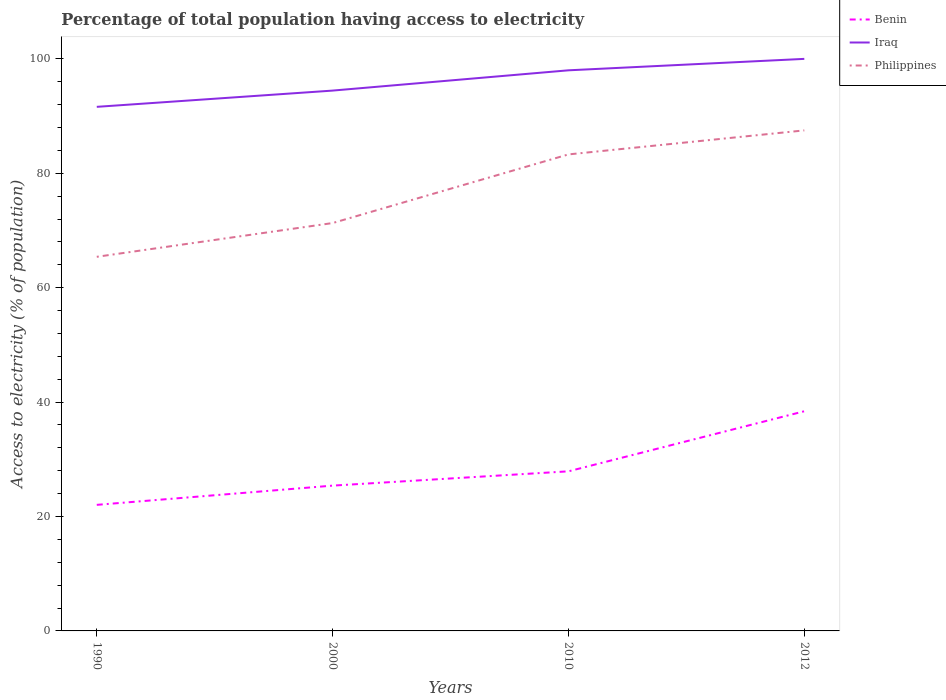How many different coloured lines are there?
Offer a terse response. 3. Across all years, what is the maximum percentage of population that have access to electricity in Benin?
Give a very brief answer. 22.04. What is the total percentage of population that have access to electricity in Philippines in the graph?
Ensure brevity in your answer.  -16.2. What is the difference between the highest and the second highest percentage of population that have access to electricity in Benin?
Your answer should be very brief. 16.36. What is the difference between the highest and the lowest percentage of population that have access to electricity in Benin?
Your answer should be very brief. 1. How many lines are there?
Offer a terse response. 3. How many years are there in the graph?
Provide a short and direct response. 4. Are the values on the major ticks of Y-axis written in scientific E-notation?
Provide a succinct answer. No. How many legend labels are there?
Make the answer very short. 3. What is the title of the graph?
Offer a terse response. Percentage of total population having access to electricity. Does "Chad" appear as one of the legend labels in the graph?
Keep it short and to the point. No. What is the label or title of the X-axis?
Your answer should be compact. Years. What is the label or title of the Y-axis?
Provide a short and direct response. Access to electricity (% of population). What is the Access to electricity (% of population) of Benin in 1990?
Your answer should be compact. 22.04. What is the Access to electricity (% of population) of Iraq in 1990?
Ensure brevity in your answer.  91.62. What is the Access to electricity (% of population) of Philippines in 1990?
Ensure brevity in your answer.  65.4. What is the Access to electricity (% of population) in Benin in 2000?
Make the answer very short. 25.4. What is the Access to electricity (% of population) in Iraq in 2000?
Give a very brief answer. 94.46. What is the Access to electricity (% of population) in Philippines in 2000?
Offer a very short reply. 71.3. What is the Access to electricity (% of population) of Benin in 2010?
Offer a very short reply. 27.9. What is the Access to electricity (% of population) in Iraq in 2010?
Your answer should be very brief. 98. What is the Access to electricity (% of population) in Philippines in 2010?
Your answer should be very brief. 83.3. What is the Access to electricity (% of population) in Benin in 2012?
Your response must be concise. 38.4. What is the Access to electricity (% of population) of Philippines in 2012?
Provide a succinct answer. 87.5. Across all years, what is the maximum Access to electricity (% of population) in Benin?
Your response must be concise. 38.4. Across all years, what is the maximum Access to electricity (% of population) of Iraq?
Make the answer very short. 100. Across all years, what is the maximum Access to electricity (% of population) of Philippines?
Offer a very short reply. 87.5. Across all years, what is the minimum Access to electricity (% of population) in Benin?
Offer a very short reply. 22.04. Across all years, what is the minimum Access to electricity (% of population) in Iraq?
Provide a short and direct response. 91.62. Across all years, what is the minimum Access to electricity (% of population) in Philippines?
Your response must be concise. 65.4. What is the total Access to electricity (% of population) of Benin in the graph?
Make the answer very short. 113.74. What is the total Access to electricity (% of population) of Iraq in the graph?
Give a very brief answer. 384.07. What is the total Access to electricity (% of population) in Philippines in the graph?
Offer a terse response. 307.5. What is the difference between the Access to electricity (% of population) in Benin in 1990 and that in 2000?
Provide a short and direct response. -3.36. What is the difference between the Access to electricity (% of population) in Iraq in 1990 and that in 2000?
Give a very brief answer. -2.84. What is the difference between the Access to electricity (% of population) of Benin in 1990 and that in 2010?
Provide a succinct answer. -5.86. What is the difference between the Access to electricity (% of population) of Iraq in 1990 and that in 2010?
Provide a short and direct response. -6.38. What is the difference between the Access to electricity (% of population) of Philippines in 1990 and that in 2010?
Keep it short and to the point. -17.9. What is the difference between the Access to electricity (% of population) in Benin in 1990 and that in 2012?
Make the answer very short. -16.36. What is the difference between the Access to electricity (% of population) in Iraq in 1990 and that in 2012?
Your answer should be compact. -8.38. What is the difference between the Access to electricity (% of population) in Philippines in 1990 and that in 2012?
Make the answer very short. -22.1. What is the difference between the Access to electricity (% of population) of Iraq in 2000 and that in 2010?
Your answer should be very brief. -3.54. What is the difference between the Access to electricity (% of population) in Philippines in 2000 and that in 2010?
Your answer should be very brief. -12. What is the difference between the Access to electricity (% of population) of Iraq in 2000 and that in 2012?
Provide a short and direct response. -5.54. What is the difference between the Access to electricity (% of population) of Philippines in 2000 and that in 2012?
Provide a succinct answer. -16.2. What is the difference between the Access to electricity (% of population) in Iraq in 2010 and that in 2012?
Make the answer very short. -2. What is the difference between the Access to electricity (% of population) of Benin in 1990 and the Access to electricity (% of population) of Iraq in 2000?
Keep it short and to the point. -72.42. What is the difference between the Access to electricity (% of population) of Benin in 1990 and the Access to electricity (% of population) of Philippines in 2000?
Provide a short and direct response. -49.26. What is the difference between the Access to electricity (% of population) of Iraq in 1990 and the Access to electricity (% of population) of Philippines in 2000?
Provide a short and direct response. 20.32. What is the difference between the Access to electricity (% of population) in Benin in 1990 and the Access to electricity (% of population) in Iraq in 2010?
Provide a succinct answer. -75.96. What is the difference between the Access to electricity (% of population) of Benin in 1990 and the Access to electricity (% of population) of Philippines in 2010?
Offer a very short reply. -61.26. What is the difference between the Access to electricity (% of population) of Iraq in 1990 and the Access to electricity (% of population) of Philippines in 2010?
Your answer should be compact. 8.32. What is the difference between the Access to electricity (% of population) of Benin in 1990 and the Access to electricity (% of population) of Iraq in 2012?
Give a very brief answer. -77.96. What is the difference between the Access to electricity (% of population) in Benin in 1990 and the Access to electricity (% of population) in Philippines in 2012?
Give a very brief answer. -65.46. What is the difference between the Access to electricity (% of population) of Iraq in 1990 and the Access to electricity (% of population) of Philippines in 2012?
Your answer should be compact. 4.12. What is the difference between the Access to electricity (% of population) in Benin in 2000 and the Access to electricity (% of population) in Iraq in 2010?
Your answer should be very brief. -72.6. What is the difference between the Access to electricity (% of population) in Benin in 2000 and the Access to electricity (% of population) in Philippines in 2010?
Provide a succinct answer. -57.9. What is the difference between the Access to electricity (% of population) in Iraq in 2000 and the Access to electricity (% of population) in Philippines in 2010?
Make the answer very short. 11.16. What is the difference between the Access to electricity (% of population) in Benin in 2000 and the Access to electricity (% of population) in Iraq in 2012?
Keep it short and to the point. -74.6. What is the difference between the Access to electricity (% of population) of Benin in 2000 and the Access to electricity (% of population) of Philippines in 2012?
Make the answer very short. -62.1. What is the difference between the Access to electricity (% of population) in Iraq in 2000 and the Access to electricity (% of population) in Philippines in 2012?
Your answer should be compact. 6.96. What is the difference between the Access to electricity (% of population) in Benin in 2010 and the Access to electricity (% of population) in Iraq in 2012?
Make the answer very short. -72.1. What is the difference between the Access to electricity (% of population) in Benin in 2010 and the Access to electricity (% of population) in Philippines in 2012?
Offer a very short reply. -59.6. What is the difference between the Access to electricity (% of population) of Iraq in 2010 and the Access to electricity (% of population) of Philippines in 2012?
Ensure brevity in your answer.  10.5. What is the average Access to electricity (% of population) in Benin per year?
Offer a terse response. 28.43. What is the average Access to electricity (% of population) of Iraq per year?
Provide a succinct answer. 96.02. What is the average Access to electricity (% of population) in Philippines per year?
Offer a very short reply. 76.88. In the year 1990, what is the difference between the Access to electricity (% of population) of Benin and Access to electricity (% of population) of Iraq?
Ensure brevity in your answer.  -69.58. In the year 1990, what is the difference between the Access to electricity (% of population) of Benin and Access to electricity (% of population) of Philippines?
Make the answer very short. -43.36. In the year 1990, what is the difference between the Access to electricity (% of population) in Iraq and Access to electricity (% of population) in Philippines?
Offer a very short reply. 26.22. In the year 2000, what is the difference between the Access to electricity (% of population) in Benin and Access to electricity (% of population) in Iraq?
Provide a short and direct response. -69.06. In the year 2000, what is the difference between the Access to electricity (% of population) of Benin and Access to electricity (% of population) of Philippines?
Your answer should be very brief. -45.9. In the year 2000, what is the difference between the Access to electricity (% of population) in Iraq and Access to electricity (% of population) in Philippines?
Your answer should be very brief. 23.16. In the year 2010, what is the difference between the Access to electricity (% of population) of Benin and Access to electricity (% of population) of Iraq?
Provide a short and direct response. -70.1. In the year 2010, what is the difference between the Access to electricity (% of population) in Benin and Access to electricity (% of population) in Philippines?
Provide a short and direct response. -55.4. In the year 2012, what is the difference between the Access to electricity (% of population) in Benin and Access to electricity (% of population) in Iraq?
Your response must be concise. -61.6. In the year 2012, what is the difference between the Access to electricity (% of population) in Benin and Access to electricity (% of population) in Philippines?
Give a very brief answer. -49.1. In the year 2012, what is the difference between the Access to electricity (% of population) of Iraq and Access to electricity (% of population) of Philippines?
Keep it short and to the point. 12.5. What is the ratio of the Access to electricity (% of population) in Benin in 1990 to that in 2000?
Your answer should be very brief. 0.87. What is the ratio of the Access to electricity (% of population) in Iraq in 1990 to that in 2000?
Provide a short and direct response. 0.97. What is the ratio of the Access to electricity (% of population) of Philippines in 1990 to that in 2000?
Keep it short and to the point. 0.92. What is the ratio of the Access to electricity (% of population) of Benin in 1990 to that in 2010?
Offer a terse response. 0.79. What is the ratio of the Access to electricity (% of population) in Iraq in 1990 to that in 2010?
Offer a very short reply. 0.93. What is the ratio of the Access to electricity (% of population) of Philippines in 1990 to that in 2010?
Give a very brief answer. 0.79. What is the ratio of the Access to electricity (% of population) in Benin in 1990 to that in 2012?
Your answer should be very brief. 0.57. What is the ratio of the Access to electricity (% of population) of Iraq in 1990 to that in 2012?
Provide a succinct answer. 0.92. What is the ratio of the Access to electricity (% of population) of Philippines in 1990 to that in 2012?
Provide a succinct answer. 0.75. What is the ratio of the Access to electricity (% of population) in Benin in 2000 to that in 2010?
Provide a short and direct response. 0.91. What is the ratio of the Access to electricity (% of population) in Iraq in 2000 to that in 2010?
Give a very brief answer. 0.96. What is the ratio of the Access to electricity (% of population) of Philippines in 2000 to that in 2010?
Your answer should be very brief. 0.86. What is the ratio of the Access to electricity (% of population) of Benin in 2000 to that in 2012?
Provide a succinct answer. 0.66. What is the ratio of the Access to electricity (% of population) in Iraq in 2000 to that in 2012?
Your answer should be very brief. 0.94. What is the ratio of the Access to electricity (% of population) in Philippines in 2000 to that in 2012?
Keep it short and to the point. 0.81. What is the ratio of the Access to electricity (% of population) of Benin in 2010 to that in 2012?
Offer a very short reply. 0.73. What is the difference between the highest and the second highest Access to electricity (% of population) of Benin?
Your response must be concise. 10.5. What is the difference between the highest and the second highest Access to electricity (% of population) of Iraq?
Ensure brevity in your answer.  2. What is the difference between the highest and the lowest Access to electricity (% of population) in Benin?
Your response must be concise. 16.36. What is the difference between the highest and the lowest Access to electricity (% of population) of Iraq?
Offer a terse response. 8.38. What is the difference between the highest and the lowest Access to electricity (% of population) in Philippines?
Your answer should be very brief. 22.1. 